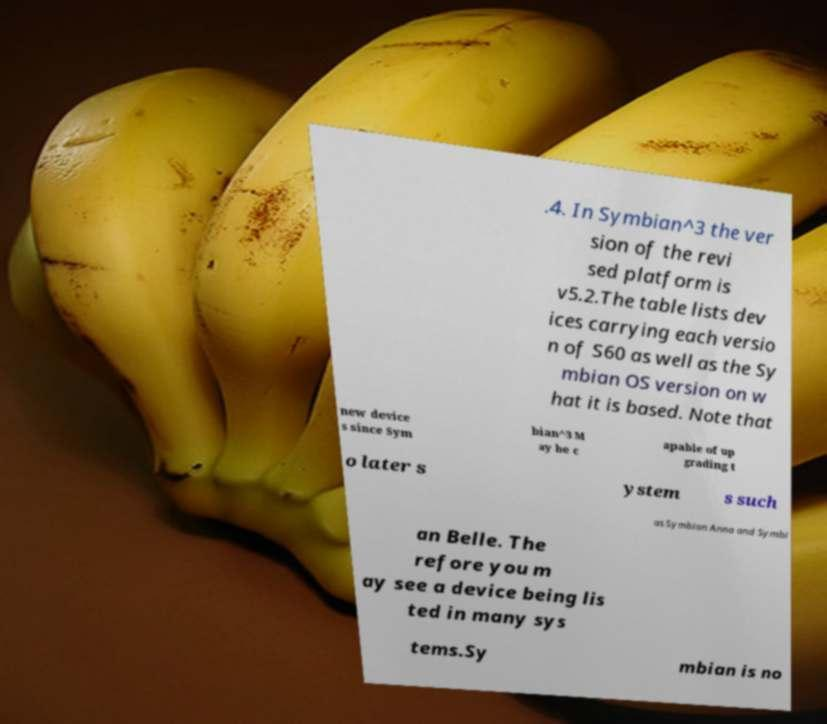I need the written content from this picture converted into text. Can you do that? .4. In Symbian^3 the ver sion of the revi sed platform is v5.2.The table lists dev ices carrying each versio n of S60 as well as the Sy mbian OS version on w hat it is based. Note that new device s since Sym bian^3 M ay be c apable of up grading t o later s ystem s such as Symbian Anna and Symbi an Belle. The refore you m ay see a device being lis ted in many sys tems.Sy mbian is no 